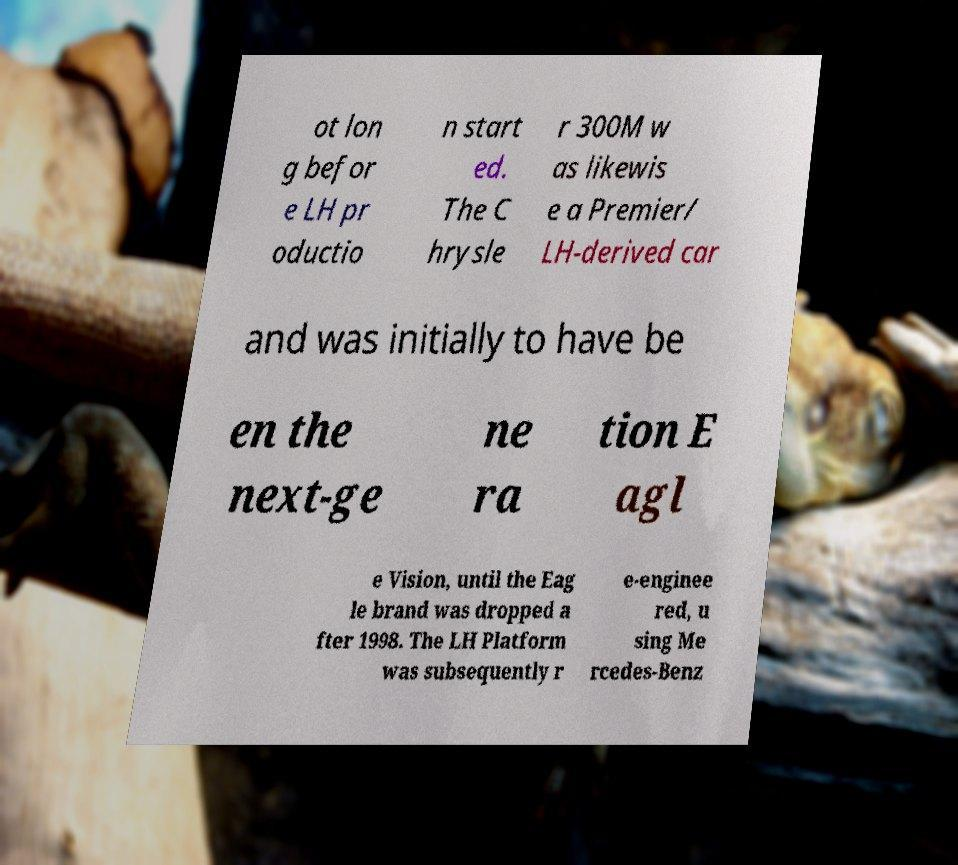Please identify and transcribe the text found in this image. ot lon g befor e LH pr oductio n start ed. The C hrysle r 300M w as likewis e a Premier/ LH-derived car and was initially to have be en the next-ge ne ra tion E agl e Vision, until the Eag le brand was dropped a fter 1998. The LH Platform was subsequently r e-enginee red, u sing Me rcedes-Benz 